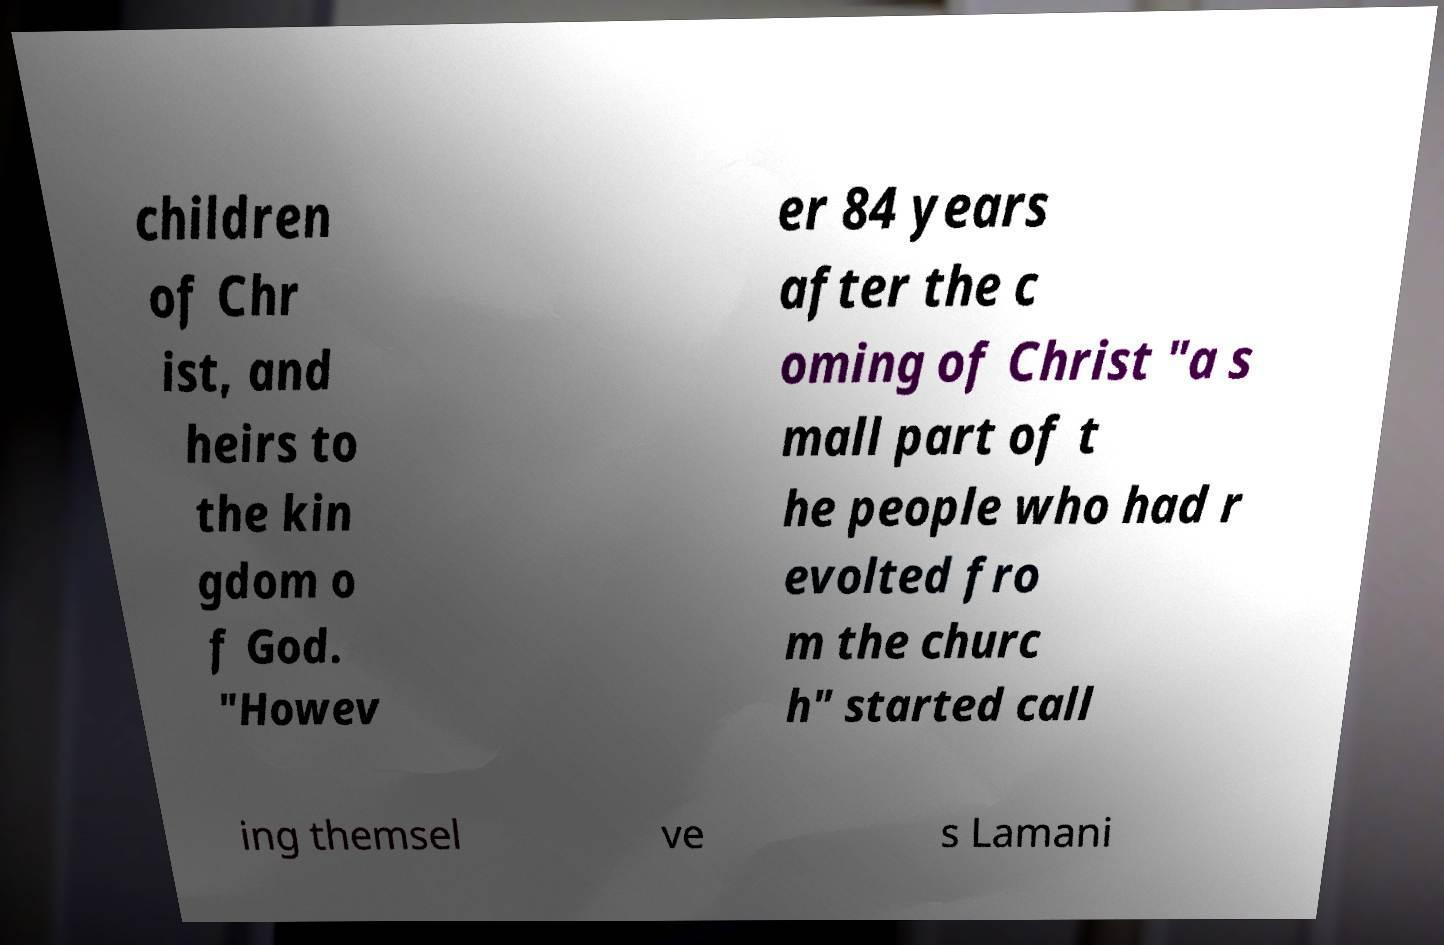Please read and relay the text visible in this image. What does it say? children of Chr ist, and heirs to the kin gdom o f God. "Howev er 84 years after the c oming of Christ "a s mall part of t he people who had r evolted fro m the churc h" started call ing themsel ve s Lamani 